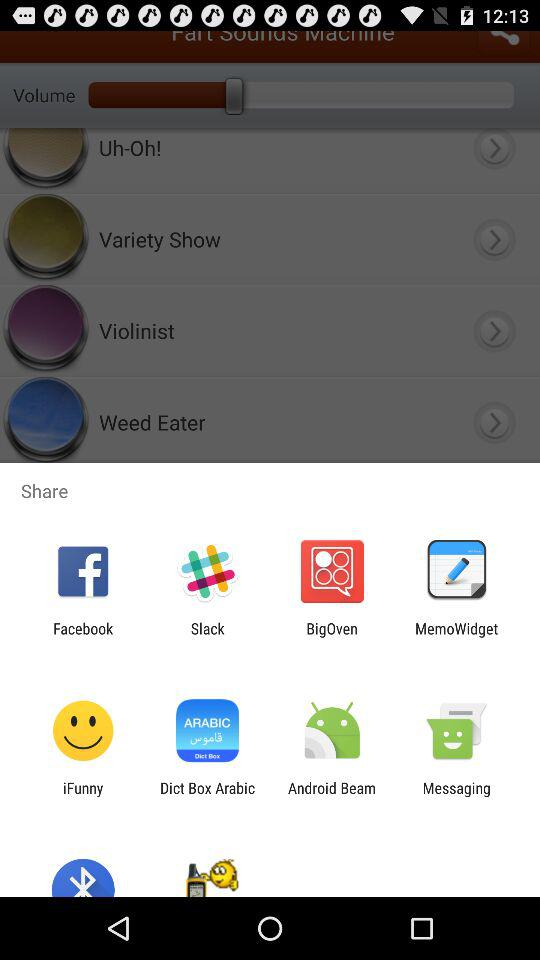What percentage of the volume has been turned on?
When the provided information is insufficient, respond with <no answer>. <no answer> 